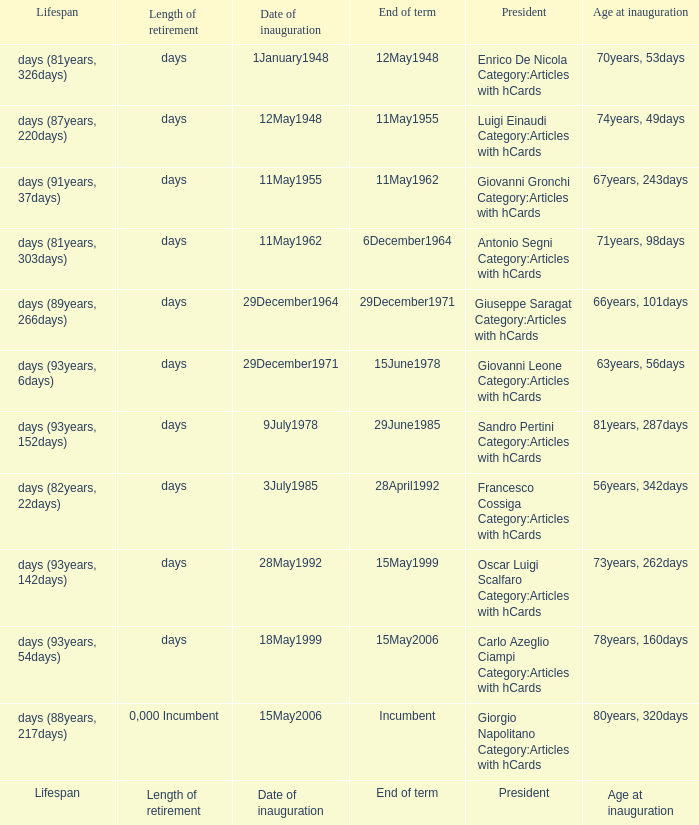What is the Length of retirement of the President with an Age at inauguration of 70years, 53days? Days. 